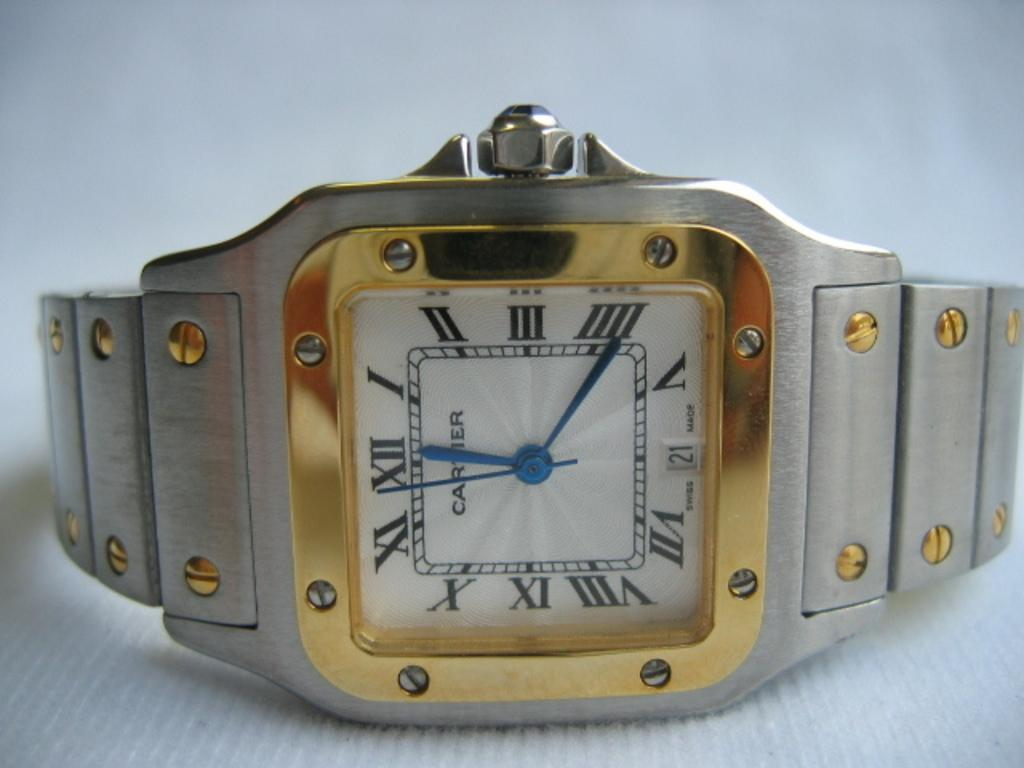Provide a one-sentence caption for the provided image. A gold cartier watch is on its side showing the time is approaching 12.22. 